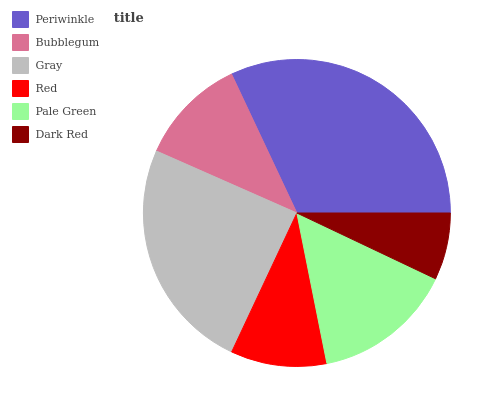Is Dark Red the minimum?
Answer yes or no. Yes. Is Periwinkle the maximum?
Answer yes or no. Yes. Is Bubblegum the minimum?
Answer yes or no. No. Is Bubblegum the maximum?
Answer yes or no. No. Is Periwinkle greater than Bubblegum?
Answer yes or no. Yes. Is Bubblegum less than Periwinkle?
Answer yes or no. Yes. Is Bubblegum greater than Periwinkle?
Answer yes or no. No. Is Periwinkle less than Bubblegum?
Answer yes or no. No. Is Pale Green the high median?
Answer yes or no. Yes. Is Bubblegum the low median?
Answer yes or no. Yes. Is Bubblegum the high median?
Answer yes or no. No. Is Dark Red the low median?
Answer yes or no. No. 